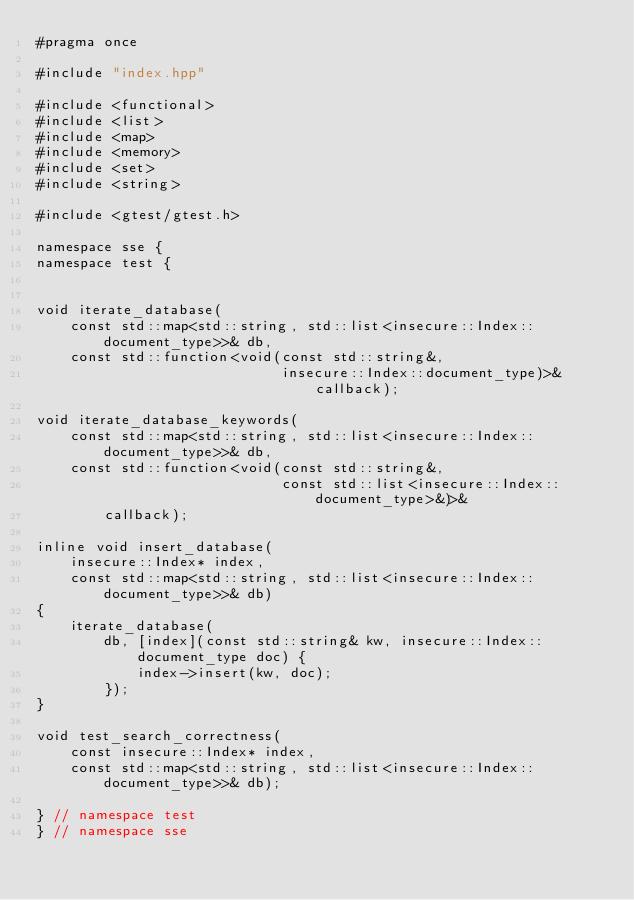<code> <loc_0><loc_0><loc_500><loc_500><_C++_>#pragma once

#include "index.hpp"

#include <functional>
#include <list>
#include <map>
#include <memory>
#include <set>
#include <string>

#include <gtest/gtest.h>

namespace sse {
namespace test {


void iterate_database(
    const std::map<std::string, std::list<insecure::Index::document_type>>& db,
    const std::function<void(const std::string&,
                             insecure::Index::document_type)>& callback);

void iterate_database_keywords(
    const std::map<std::string, std::list<insecure::Index::document_type>>& db,
    const std::function<void(const std::string&,
                             const std::list<insecure::Index::document_type>&)>&
        callback);

inline void insert_database(
    insecure::Index* index,
    const std::map<std::string, std::list<insecure::Index::document_type>>& db)
{
    iterate_database(
        db, [index](const std::string& kw, insecure::Index::document_type doc) {
            index->insert(kw, doc);
        });
}

void test_search_correctness(
    const insecure::Index* index,
    const std::map<std::string, std::list<insecure::Index::document_type>>& db);

} // namespace test
} // namespace sse</code> 